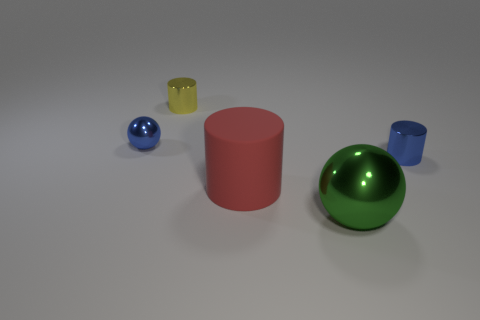Subtract all tiny shiny cylinders. How many cylinders are left? 1 Add 2 red shiny things. How many objects exist? 7 Subtract all green balls. How many balls are left? 1 Subtract all spheres. How many objects are left? 3 Subtract all red spheres. How many yellow cylinders are left? 1 Subtract all tiny red shiny blocks. Subtract all green metallic objects. How many objects are left? 4 Add 3 tiny metallic objects. How many tiny metallic objects are left? 6 Add 2 green metallic objects. How many green metallic objects exist? 3 Subtract 0 purple blocks. How many objects are left? 5 Subtract 1 spheres. How many spheres are left? 1 